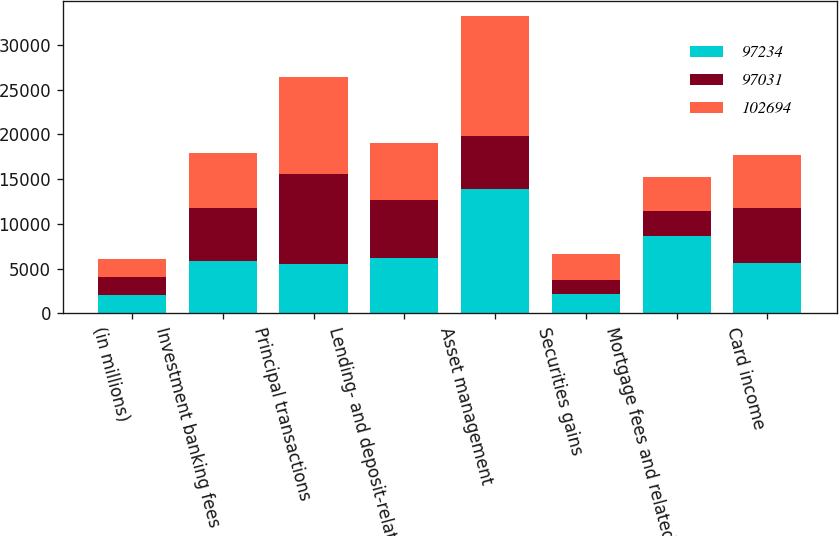<chart> <loc_0><loc_0><loc_500><loc_500><stacked_bar_chart><ecel><fcel>(in millions)<fcel>Investment banking fees<fcel>Principal transactions<fcel>Lending- and deposit-related<fcel>Asset management<fcel>Securities gains<fcel>Mortgage fees and related<fcel>Card income<nl><fcel>97234<fcel>2012<fcel>5808<fcel>5536<fcel>6196<fcel>13868<fcel>2110<fcel>8687<fcel>5658<nl><fcel>97031<fcel>2011<fcel>5911<fcel>10005<fcel>6458<fcel>5891<fcel>1593<fcel>2721<fcel>6158<nl><fcel>102694<fcel>2010<fcel>6190<fcel>10894<fcel>6340<fcel>13499<fcel>2965<fcel>3870<fcel>5891<nl></chart> 